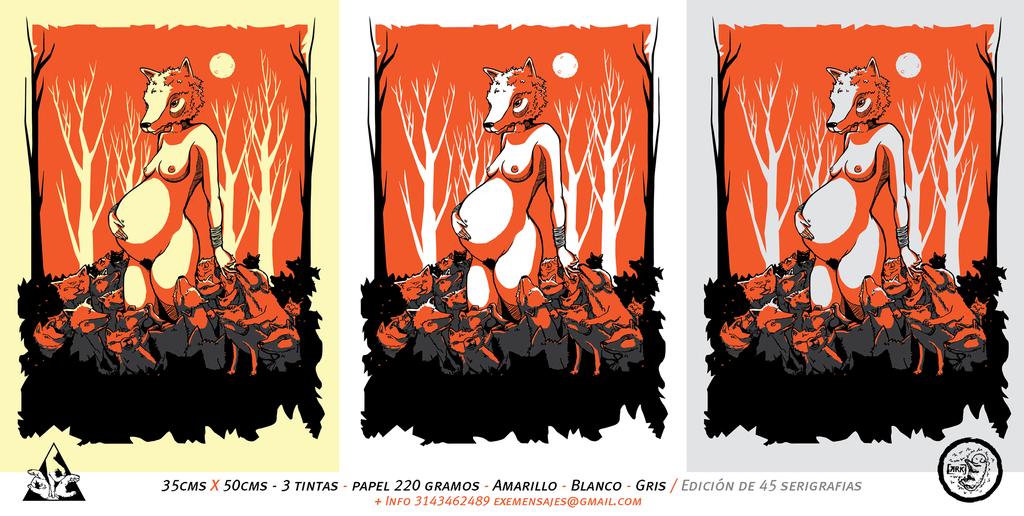What dimensions are mentioned here?
Give a very brief answer. 35cms x 50cms. Which email address to contact for info?
Offer a terse response. Exemensales@gmail.com. 